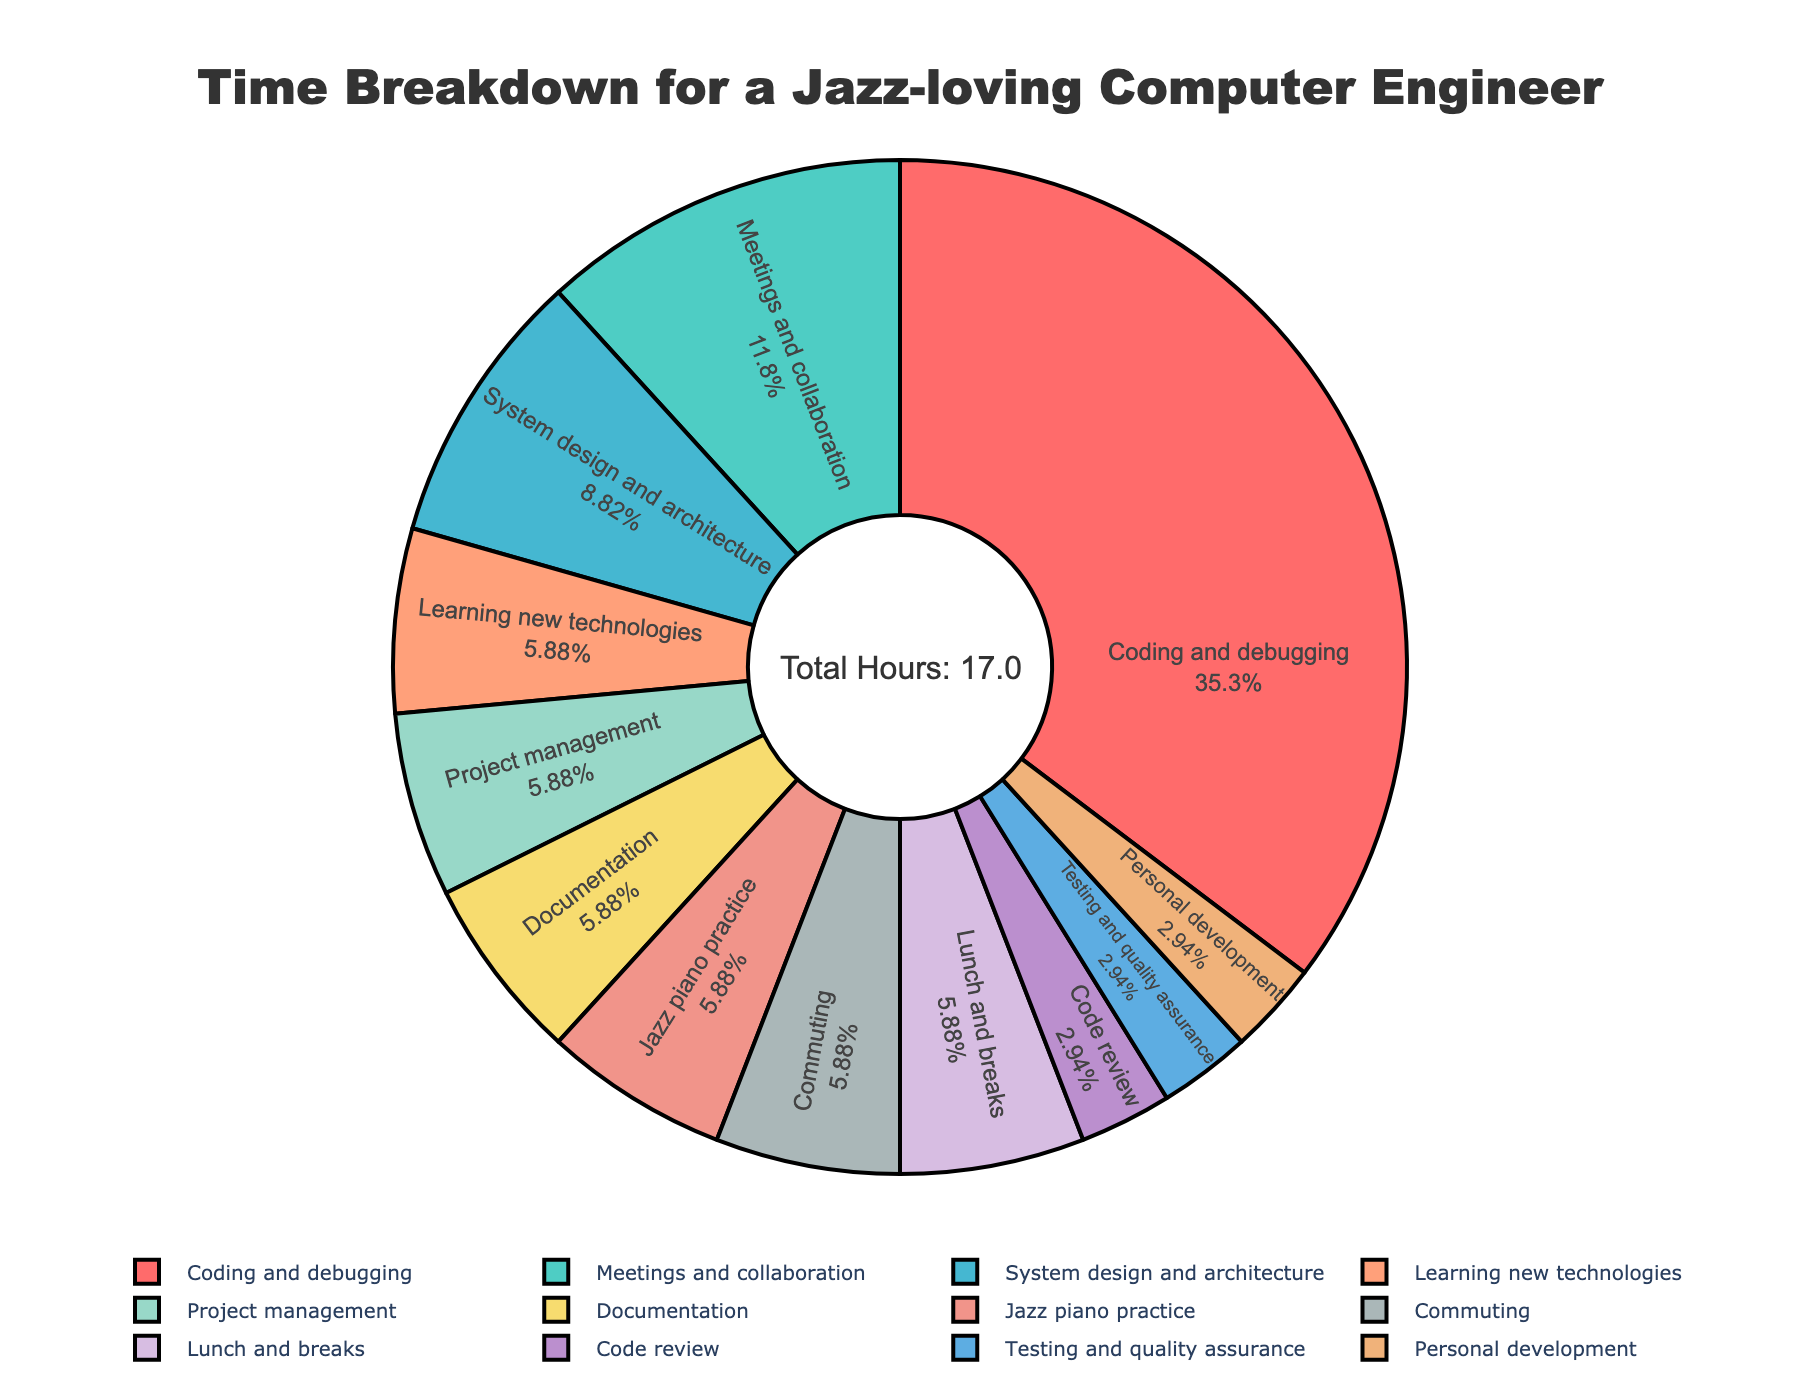Which activity takes up the most hours? The largest segment of the pie chart belongs to "Coding and debugging", indicating it occupies the most hours.
Answer: Coding and debugging What is the combined time spent on meetings and collaboration, and system design and architecture? The pie chart shows 2 hours for "Meetings and collaboration" and 1.5 hours for "System design and architecture". Adding these gives 2 + 1.5 = 3.5 hours.
Answer: 3.5 hours Which activity has the smallest time allocation? The smallest segment in the pie chart is shared between "Code review", "Testing and quality assurance", and "Personal development", each with 0.5 hours.
Answer: Code review, Testing and quality assurance, Personal development How does the time spent on learning new technologies compare to time spent on project management? The pie chart shows 1 hour for "Learning new technologies" and 1 hour for "Project management", meaning they are equal.
Answer: Equal What percentage of the total time is spent on coding and debugging? The segment for "Coding and debugging" dominates the chart, indicating it is 6 hours out of the total 16 hours. So, (6/16) * 100 = 37.5%.
Answer: 37.5% Which is higher: the time spent on personal development or the time spent on documentation? The pie chart shows 0.5 hours for "Personal development" and 1 hour for "Documentation". Since 1 hour is greater than 0.5 hours, more time is spent on documentation.
Answer: Documentation What are the activities with more than 1 hour allocation? The pie chart highlights the following: "Coding and debugging" (6 hours), "Meetings and collaboration" (2 hours), "System design and architecture" (1.5 hours), "Learning new technologies" (1 hour), "Project management" (1 hour), "Documentation" (1 hour), "Jazz piano practice" (1 hour), "Commuting" (1 hour), "Lunch and breaks" (1 hour).
Answer: Coding and debugging, Meetings and collaboration, System design and architecture, Learning new technologies, Project management, Documentation, Jazz piano practice, Commuting, Lunch and breaks What is the total time spent on activities related to work (excluding Jazz piano practice and Personal development)? Summing the hours for "Coding and debugging" (6), "Meetings and collaboration" (2), "System design and architecture" (1.5), "Learning new technologies" (1), "Project management" (1), "Documentation" (1), "Code review" (0.5), and "Testing and quality assurance" (0.5) totals 13.5 hours.
Answer: 13.5 hours What is the ratio of time spent on coding and debugging to time spent on lunches and breaks? The pie chart shows 6 hours for "Coding and debugging" and 1 hour for "Lunch and breaks". The ratio is therefore 6:1.
Answer: 6:1 If the time spent on coding and debugging was reduced by 1 hour, how much total time would be allocated to coding and debugging and project management combined? After reducing "Coding and debugging" by 1 hour, it becomes 5 hours. Adding this to "Project management" which is 1 hour, gives 5 + 1 = 6 hours.
Answer: 6 hours 